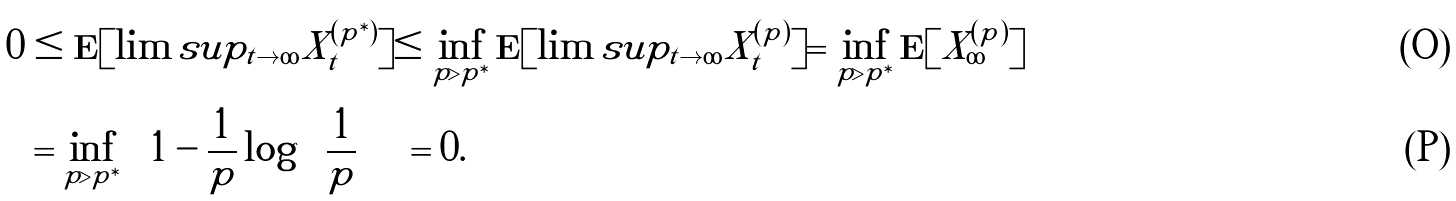Convert formula to latex. <formula><loc_0><loc_0><loc_500><loc_500>0 & \leq \mathbf E [ \lim s u p _ { t \to \infty } X ^ { ( p ^ { \ast } ) } _ { t } ] \leq \inf _ { p > p ^ { \ast } } \mathbf E [ \lim s u p _ { t \to \infty } X ^ { ( p ) } _ { t } ] = \inf _ { p > p ^ { \ast } } \mathbf E [ X ^ { ( p ) } _ { \infty } ] \\ & = \inf _ { p > p ^ { \ast } } \left ( 1 - \frac { 1 } { p } \log \left ( \frac { 1 } { p } \right ) \right ) = 0 .</formula> 